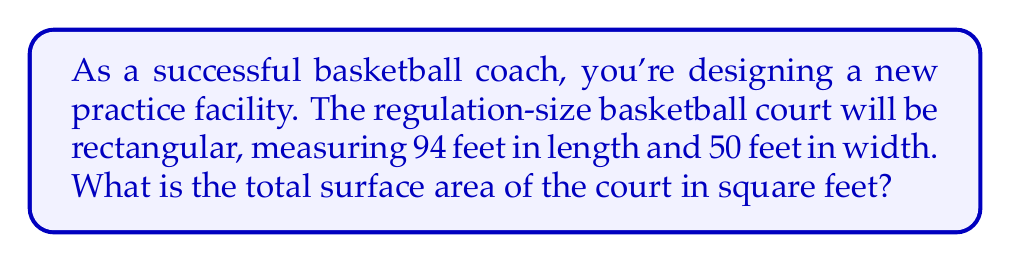Solve this math problem. To solve this problem, we need to calculate the area of a rectangle. The formula for the area of a rectangle is:

$$A = l \times w$$

Where:
$A$ = Area
$l$ = Length
$w$ = Width

Given:
- Length of the court = 94 feet
- Width of the court = 50 feet

Step 1: Substitute the values into the formula
$$A = 94 \text{ ft} \times 50 \text{ ft}$$

Step 2: Multiply the length and width
$$A = 4,700 \text{ sq ft}$$

Therefore, the total surface area of the basketball court is 4,700 square feet.
Answer: 4,700 sq ft 